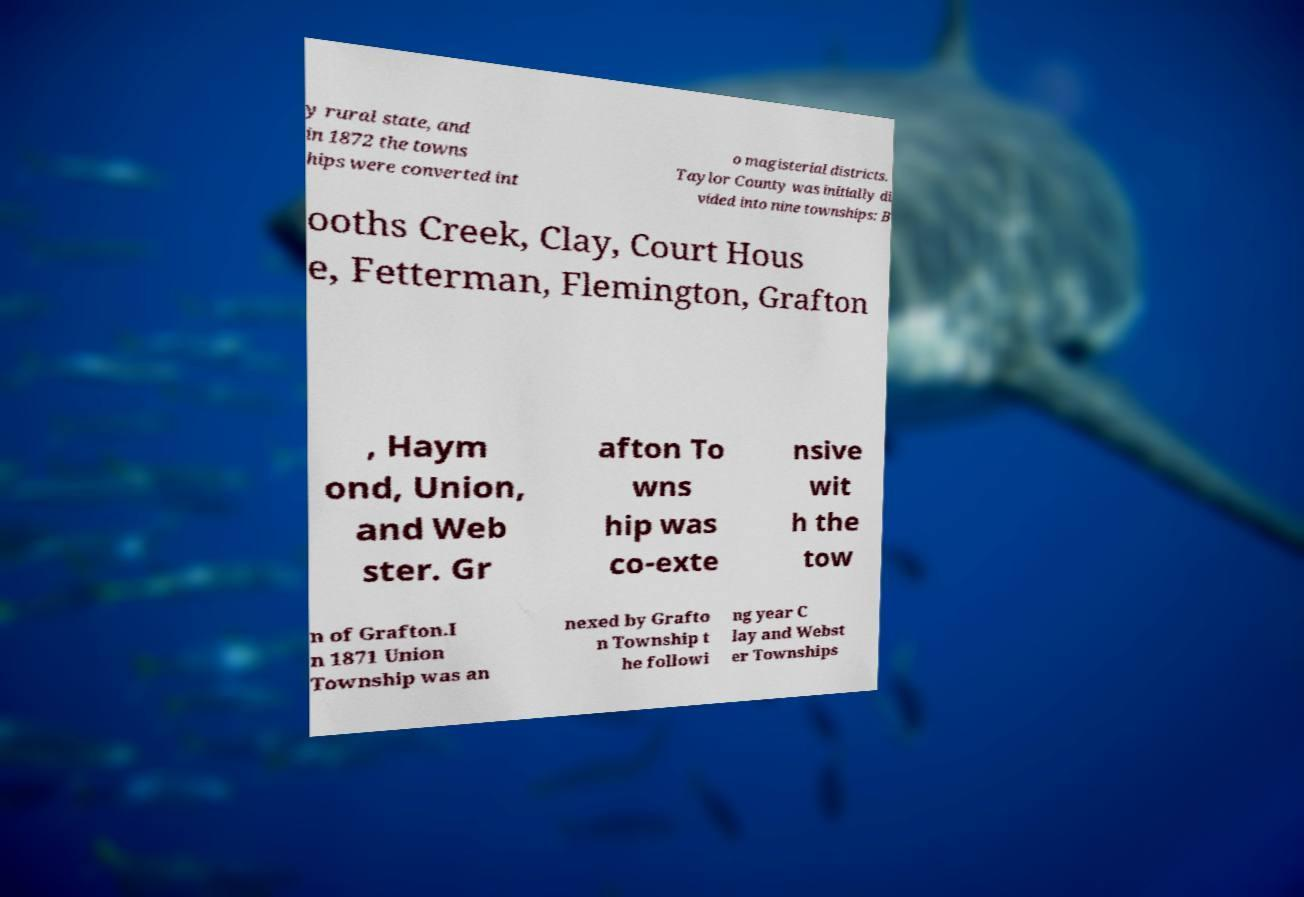Please read and relay the text visible in this image. What does it say? y rural state, and in 1872 the towns hips were converted int o magisterial districts. Taylor County was initially di vided into nine townships: B ooths Creek, Clay, Court Hous e, Fetterman, Flemington, Grafton , Haym ond, Union, and Web ster. Gr afton To wns hip was co-exte nsive wit h the tow n of Grafton.I n 1871 Union Township was an nexed by Grafto n Township t he followi ng year C lay and Webst er Townships 